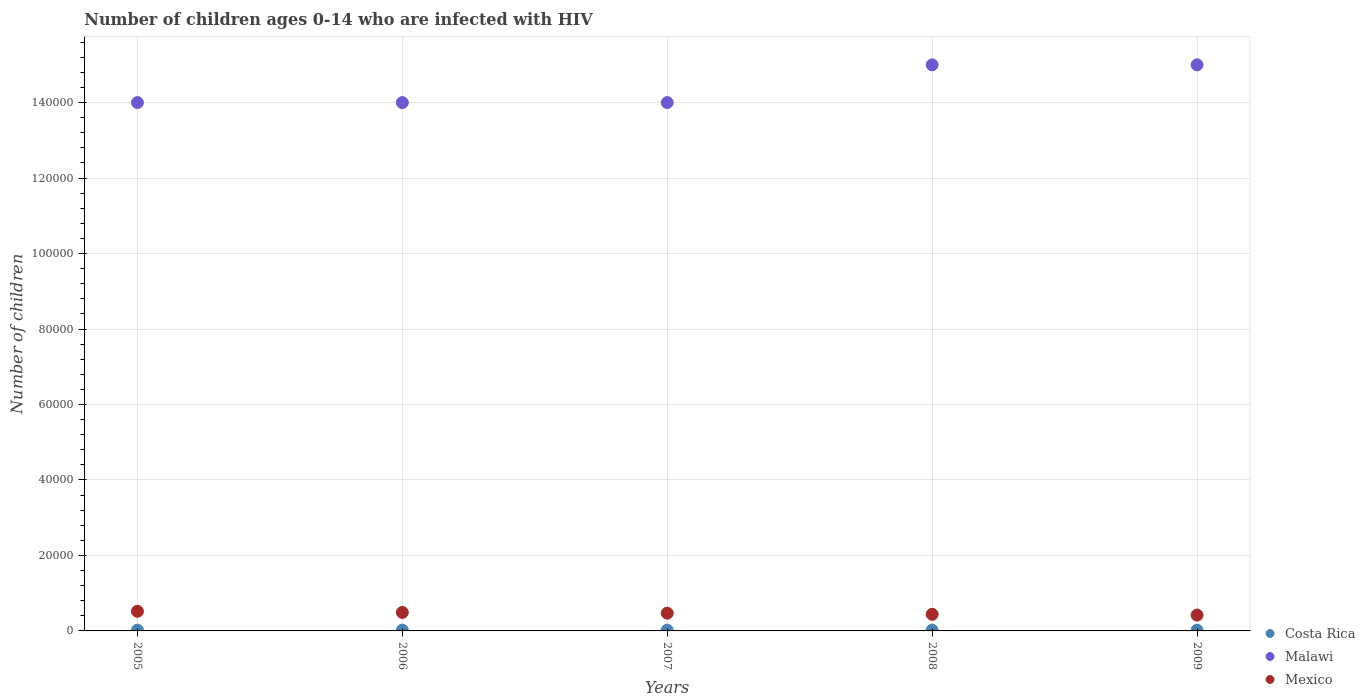How many different coloured dotlines are there?
Make the answer very short. 3. Is the number of dotlines equal to the number of legend labels?
Your response must be concise. Yes. What is the number of HIV infected children in Malawi in 2007?
Make the answer very short. 1.40e+05. Across all years, what is the maximum number of HIV infected children in Costa Rica?
Keep it short and to the point. 200. Across all years, what is the minimum number of HIV infected children in Mexico?
Provide a short and direct response. 4200. In which year was the number of HIV infected children in Costa Rica maximum?
Give a very brief answer. 2005. What is the total number of HIV infected children in Costa Rica in the graph?
Give a very brief answer. 1000. What is the difference between the number of HIV infected children in Costa Rica in 2005 and that in 2007?
Your answer should be very brief. 0. What is the difference between the number of HIV infected children in Malawi in 2005 and the number of HIV infected children in Costa Rica in 2008?
Your answer should be compact. 1.40e+05. In the year 2007, what is the difference between the number of HIV infected children in Mexico and number of HIV infected children in Malawi?
Your answer should be compact. -1.35e+05. In how many years, is the number of HIV infected children in Costa Rica greater than 132000?
Provide a succinct answer. 0. What is the ratio of the number of HIV infected children in Mexico in 2007 to that in 2008?
Keep it short and to the point. 1.07. Is the number of HIV infected children in Malawi in 2007 less than that in 2008?
Make the answer very short. Yes. What is the difference between the highest and the second highest number of HIV infected children in Mexico?
Ensure brevity in your answer.  300. What is the difference between the highest and the lowest number of HIV infected children in Malawi?
Provide a short and direct response. 10000. Is the sum of the number of HIV infected children in Malawi in 2006 and 2007 greater than the maximum number of HIV infected children in Costa Rica across all years?
Your response must be concise. Yes. Is it the case that in every year, the sum of the number of HIV infected children in Malawi and number of HIV infected children in Costa Rica  is greater than the number of HIV infected children in Mexico?
Offer a terse response. Yes. Does the number of HIV infected children in Costa Rica monotonically increase over the years?
Keep it short and to the point. No. Is the number of HIV infected children in Mexico strictly greater than the number of HIV infected children in Malawi over the years?
Give a very brief answer. No. How many dotlines are there?
Ensure brevity in your answer.  3. How many years are there in the graph?
Provide a succinct answer. 5. Are the values on the major ticks of Y-axis written in scientific E-notation?
Give a very brief answer. No. Does the graph contain any zero values?
Give a very brief answer. No. Does the graph contain grids?
Offer a terse response. Yes. Where does the legend appear in the graph?
Ensure brevity in your answer.  Bottom right. How many legend labels are there?
Provide a short and direct response. 3. What is the title of the graph?
Keep it short and to the point. Number of children ages 0-14 who are infected with HIV. What is the label or title of the X-axis?
Your response must be concise. Years. What is the label or title of the Y-axis?
Ensure brevity in your answer.  Number of children. What is the Number of children in Mexico in 2005?
Ensure brevity in your answer.  5200. What is the Number of children of Costa Rica in 2006?
Ensure brevity in your answer.  200. What is the Number of children of Malawi in 2006?
Provide a succinct answer. 1.40e+05. What is the Number of children in Mexico in 2006?
Ensure brevity in your answer.  4900. What is the Number of children of Mexico in 2007?
Give a very brief answer. 4700. What is the Number of children in Costa Rica in 2008?
Ensure brevity in your answer.  200. What is the Number of children in Malawi in 2008?
Ensure brevity in your answer.  1.50e+05. What is the Number of children in Mexico in 2008?
Keep it short and to the point. 4400. What is the Number of children of Malawi in 2009?
Make the answer very short. 1.50e+05. What is the Number of children of Mexico in 2009?
Provide a short and direct response. 4200. Across all years, what is the maximum Number of children of Mexico?
Ensure brevity in your answer.  5200. Across all years, what is the minimum Number of children in Costa Rica?
Offer a very short reply. 200. Across all years, what is the minimum Number of children of Mexico?
Provide a short and direct response. 4200. What is the total Number of children of Costa Rica in the graph?
Give a very brief answer. 1000. What is the total Number of children in Malawi in the graph?
Make the answer very short. 7.20e+05. What is the total Number of children in Mexico in the graph?
Keep it short and to the point. 2.34e+04. What is the difference between the Number of children of Costa Rica in 2005 and that in 2006?
Keep it short and to the point. 0. What is the difference between the Number of children of Mexico in 2005 and that in 2006?
Ensure brevity in your answer.  300. What is the difference between the Number of children of Malawi in 2005 and that in 2007?
Your response must be concise. 0. What is the difference between the Number of children of Mexico in 2005 and that in 2007?
Give a very brief answer. 500. What is the difference between the Number of children of Malawi in 2005 and that in 2008?
Provide a short and direct response. -10000. What is the difference between the Number of children in Mexico in 2005 and that in 2008?
Provide a short and direct response. 800. What is the difference between the Number of children in Malawi in 2005 and that in 2009?
Provide a succinct answer. -10000. What is the difference between the Number of children of Mexico in 2006 and that in 2007?
Make the answer very short. 200. What is the difference between the Number of children of Malawi in 2006 and that in 2008?
Your response must be concise. -10000. What is the difference between the Number of children in Mexico in 2006 and that in 2008?
Keep it short and to the point. 500. What is the difference between the Number of children of Malawi in 2006 and that in 2009?
Your answer should be very brief. -10000. What is the difference between the Number of children of Mexico in 2006 and that in 2009?
Offer a very short reply. 700. What is the difference between the Number of children of Costa Rica in 2007 and that in 2008?
Ensure brevity in your answer.  0. What is the difference between the Number of children of Malawi in 2007 and that in 2008?
Keep it short and to the point. -10000. What is the difference between the Number of children of Mexico in 2007 and that in 2008?
Provide a short and direct response. 300. What is the difference between the Number of children in Costa Rica in 2007 and that in 2009?
Provide a succinct answer. 0. What is the difference between the Number of children of Malawi in 2007 and that in 2009?
Your answer should be very brief. -10000. What is the difference between the Number of children of Costa Rica in 2008 and that in 2009?
Make the answer very short. 0. What is the difference between the Number of children in Mexico in 2008 and that in 2009?
Your response must be concise. 200. What is the difference between the Number of children in Costa Rica in 2005 and the Number of children in Malawi in 2006?
Ensure brevity in your answer.  -1.40e+05. What is the difference between the Number of children in Costa Rica in 2005 and the Number of children in Mexico in 2006?
Give a very brief answer. -4700. What is the difference between the Number of children in Malawi in 2005 and the Number of children in Mexico in 2006?
Give a very brief answer. 1.35e+05. What is the difference between the Number of children in Costa Rica in 2005 and the Number of children in Malawi in 2007?
Provide a short and direct response. -1.40e+05. What is the difference between the Number of children of Costa Rica in 2005 and the Number of children of Mexico in 2007?
Keep it short and to the point. -4500. What is the difference between the Number of children in Malawi in 2005 and the Number of children in Mexico in 2007?
Ensure brevity in your answer.  1.35e+05. What is the difference between the Number of children in Costa Rica in 2005 and the Number of children in Malawi in 2008?
Give a very brief answer. -1.50e+05. What is the difference between the Number of children of Costa Rica in 2005 and the Number of children of Mexico in 2008?
Your answer should be compact. -4200. What is the difference between the Number of children in Malawi in 2005 and the Number of children in Mexico in 2008?
Your answer should be compact. 1.36e+05. What is the difference between the Number of children of Costa Rica in 2005 and the Number of children of Malawi in 2009?
Your response must be concise. -1.50e+05. What is the difference between the Number of children in Costa Rica in 2005 and the Number of children in Mexico in 2009?
Keep it short and to the point. -4000. What is the difference between the Number of children of Malawi in 2005 and the Number of children of Mexico in 2009?
Ensure brevity in your answer.  1.36e+05. What is the difference between the Number of children of Costa Rica in 2006 and the Number of children of Malawi in 2007?
Make the answer very short. -1.40e+05. What is the difference between the Number of children in Costa Rica in 2006 and the Number of children in Mexico in 2007?
Ensure brevity in your answer.  -4500. What is the difference between the Number of children of Malawi in 2006 and the Number of children of Mexico in 2007?
Your response must be concise. 1.35e+05. What is the difference between the Number of children of Costa Rica in 2006 and the Number of children of Malawi in 2008?
Offer a terse response. -1.50e+05. What is the difference between the Number of children in Costa Rica in 2006 and the Number of children in Mexico in 2008?
Your answer should be very brief. -4200. What is the difference between the Number of children of Malawi in 2006 and the Number of children of Mexico in 2008?
Provide a short and direct response. 1.36e+05. What is the difference between the Number of children in Costa Rica in 2006 and the Number of children in Malawi in 2009?
Your response must be concise. -1.50e+05. What is the difference between the Number of children in Costa Rica in 2006 and the Number of children in Mexico in 2009?
Make the answer very short. -4000. What is the difference between the Number of children of Malawi in 2006 and the Number of children of Mexico in 2009?
Your answer should be very brief. 1.36e+05. What is the difference between the Number of children in Costa Rica in 2007 and the Number of children in Malawi in 2008?
Provide a short and direct response. -1.50e+05. What is the difference between the Number of children in Costa Rica in 2007 and the Number of children in Mexico in 2008?
Provide a short and direct response. -4200. What is the difference between the Number of children in Malawi in 2007 and the Number of children in Mexico in 2008?
Offer a terse response. 1.36e+05. What is the difference between the Number of children in Costa Rica in 2007 and the Number of children in Malawi in 2009?
Ensure brevity in your answer.  -1.50e+05. What is the difference between the Number of children of Costa Rica in 2007 and the Number of children of Mexico in 2009?
Offer a terse response. -4000. What is the difference between the Number of children in Malawi in 2007 and the Number of children in Mexico in 2009?
Offer a very short reply. 1.36e+05. What is the difference between the Number of children of Costa Rica in 2008 and the Number of children of Malawi in 2009?
Ensure brevity in your answer.  -1.50e+05. What is the difference between the Number of children in Costa Rica in 2008 and the Number of children in Mexico in 2009?
Your response must be concise. -4000. What is the difference between the Number of children in Malawi in 2008 and the Number of children in Mexico in 2009?
Your response must be concise. 1.46e+05. What is the average Number of children in Malawi per year?
Your answer should be compact. 1.44e+05. What is the average Number of children in Mexico per year?
Your answer should be very brief. 4680. In the year 2005, what is the difference between the Number of children in Costa Rica and Number of children in Malawi?
Offer a very short reply. -1.40e+05. In the year 2005, what is the difference between the Number of children in Costa Rica and Number of children in Mexico?
Give a very brief answer. -5000. In the year 2005, what is the difference between the Number of children of Malawi and Number of children of Mexico?
Your answer should be very brief. 1.35e+05. In the year 2006, what is the difference between the Number of children in Costa Rica and Number of children in Malawi?
Offer a terse response. -1.40e+05. In the year 2006, what is the difference between the Number of children of Costa Rica and Number of children of Mexico?
Ensure brevity in your answer.  -4700. In the year 2006, what is the difference between the Number of children of Malawi and Number of children of Mexico?
Ensure brevity in your answer.  1.35e+05. In the year 2007, what is the difference between the Number of children in Costa Rica and Number of children in Malawi?
Offer a very short reply. -1.40e+05. In the year 2007, what is the difference between the Number of children of Costa Rica and Number of children of Mexico?
Offer a terse response. -4500. In the year 2007, what is the difference between the Number of children of Malawi and Number of children of Mexico?
Keep it short and to the point. 1.35e+05. In the year 2008, what is the difference between the Number of children in Costa Rica and Number of children in Malawi?
Provide a short and direct response. -1.50e+05. In the year 2008, what is the difference between the Number of children of Costa Rica and Number of children of Mexico?
Offer a terse response. -4200. In the year 2008, what is the difference between the Number of children of Malawi and Number of children of Mexico?
Offer a terse response. 1.46e+05. In the year 2009, what is the difference between the Number of children of Costa Rica and Number of children of Malawi?
Offer a very short reply. -1.50e+05. In the year 2009, what is the difference between the Number of children in Costa Rica and Number of children in Mexico?
Offer a very short reply. -4000. In the year 2009, what is the difference between the Number of children in Malawi and Number of children in Mexico?
Your answer should be compact. 1.46e+05. What is the ratio of the Number of children of Costa Rica in 2005 to that in 2006?
Your answer should be very brief. 1. What is the ratio of the Number of children of Malawi in 2005 to that in 2006?
Give a very brief answer. 1. What is the ratio of the Number of children in Mexico in 2005 to that in 2006?
Provide a succinct answer. 1.06. What is the ratio of the Number of children of Costa Rica in 2005 to that in 2007?
Provide a succinct answer. 1. What is the ratio of the Number of children of Malawi in 2005 to that in 2007?
Your response must be concise. 1. What is the ratio of the Number of children in Mexico in 2005 to that in 2007?
Keep it short and to the point. 1.11. What is the ratio of the Number of children in Costa Rica in 2005 to that in 2008?
Provide a short and direct response. 1. What is the ratio of the Number of children in Mexico in 2005 to that in 2008?
Provide a short and direct response. 1.18. What is the ratio of the Number of children in Costa Rica in 2005 to that in 2009?
Your answer should be very brief. 1. What is the ratio of the Number of children in Mexico in 2005 to that in 2009?
Your answer should be very brief. 1.24. What is the ratio of the Number of children of Malawi in 2006 to that in 2007?
Provide a succinct answer. 1. What is the ratio of the Number of children in Mexico in 2006 to that in 2007?
Your answer should be compact. 1.04. What is the ratio of the Number of children of Mexico in 2006 to that in 2008?
Make the answer very short. 1.11. What is the ratio of the Number of children of Malawi in 2006 to that in 2009?
Your response must be concise. 0.93. What is the ratio of the Number of children of Mexico in 2006 to that in 2009?
Offer a terse response. 1.17. What is the ratio of the Number of children in Costa Rica in 2007 to that in 2008?
Provide a succinct answer. 1. What is the ratio of the Number of children of Mexico in 2007 to that in 2008?
Offer a terse response. 1.07. What is the ratio of the Number of children in Costa Rica in 2007 to that in 2009?
Ensure brevity in your answer.  1. What is the ratio of the Number of children in Malawi in 2007 to that in 2009?
Make the answer very short. 0.93. What is the ratio of the Number of children in Mexico in 2007 to that in 2009?
Ensure brevity in your answer.  1.12. What is the ratio of the Number of children of Costa Rica in 2008 to that in 2009?
Your answer should be compact. 1. What is the ratio of the Number of children in Mexico in 2008 to that in 2009?
Keep it short and to the point. 1.05. What is the difference between the highest and the second highest Number of children of Costa Rica?
Your answer should be compact. 0. What is the difference between the highest and the second highest Number of children in Mexico?
Offer a very short reply. 300. What is the difference between the highest and the lowest Number of children of Mexico?
Your response must be concise. 1000. 